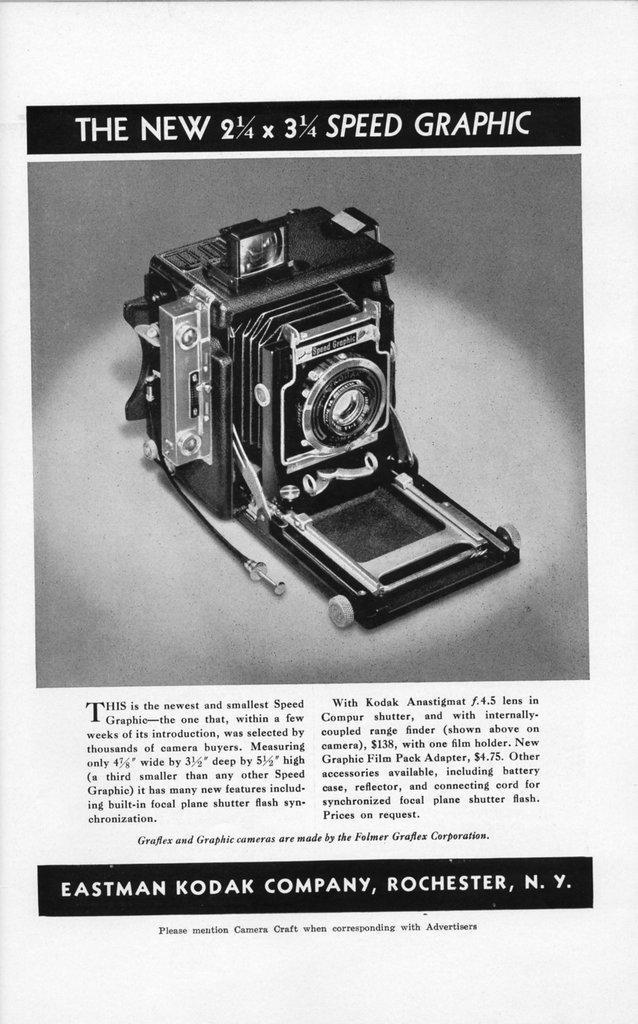How would you summarize this image in a sentence or two? In this image we can see a paper in which a camera picture is there and some text was written on the paper. 